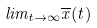Convert formula to latex. <formula><loc_0><loc_0><loc_500><loc_500>l i m _ { t \rightarrow \infty } \overline { x } ( t )</formula> 